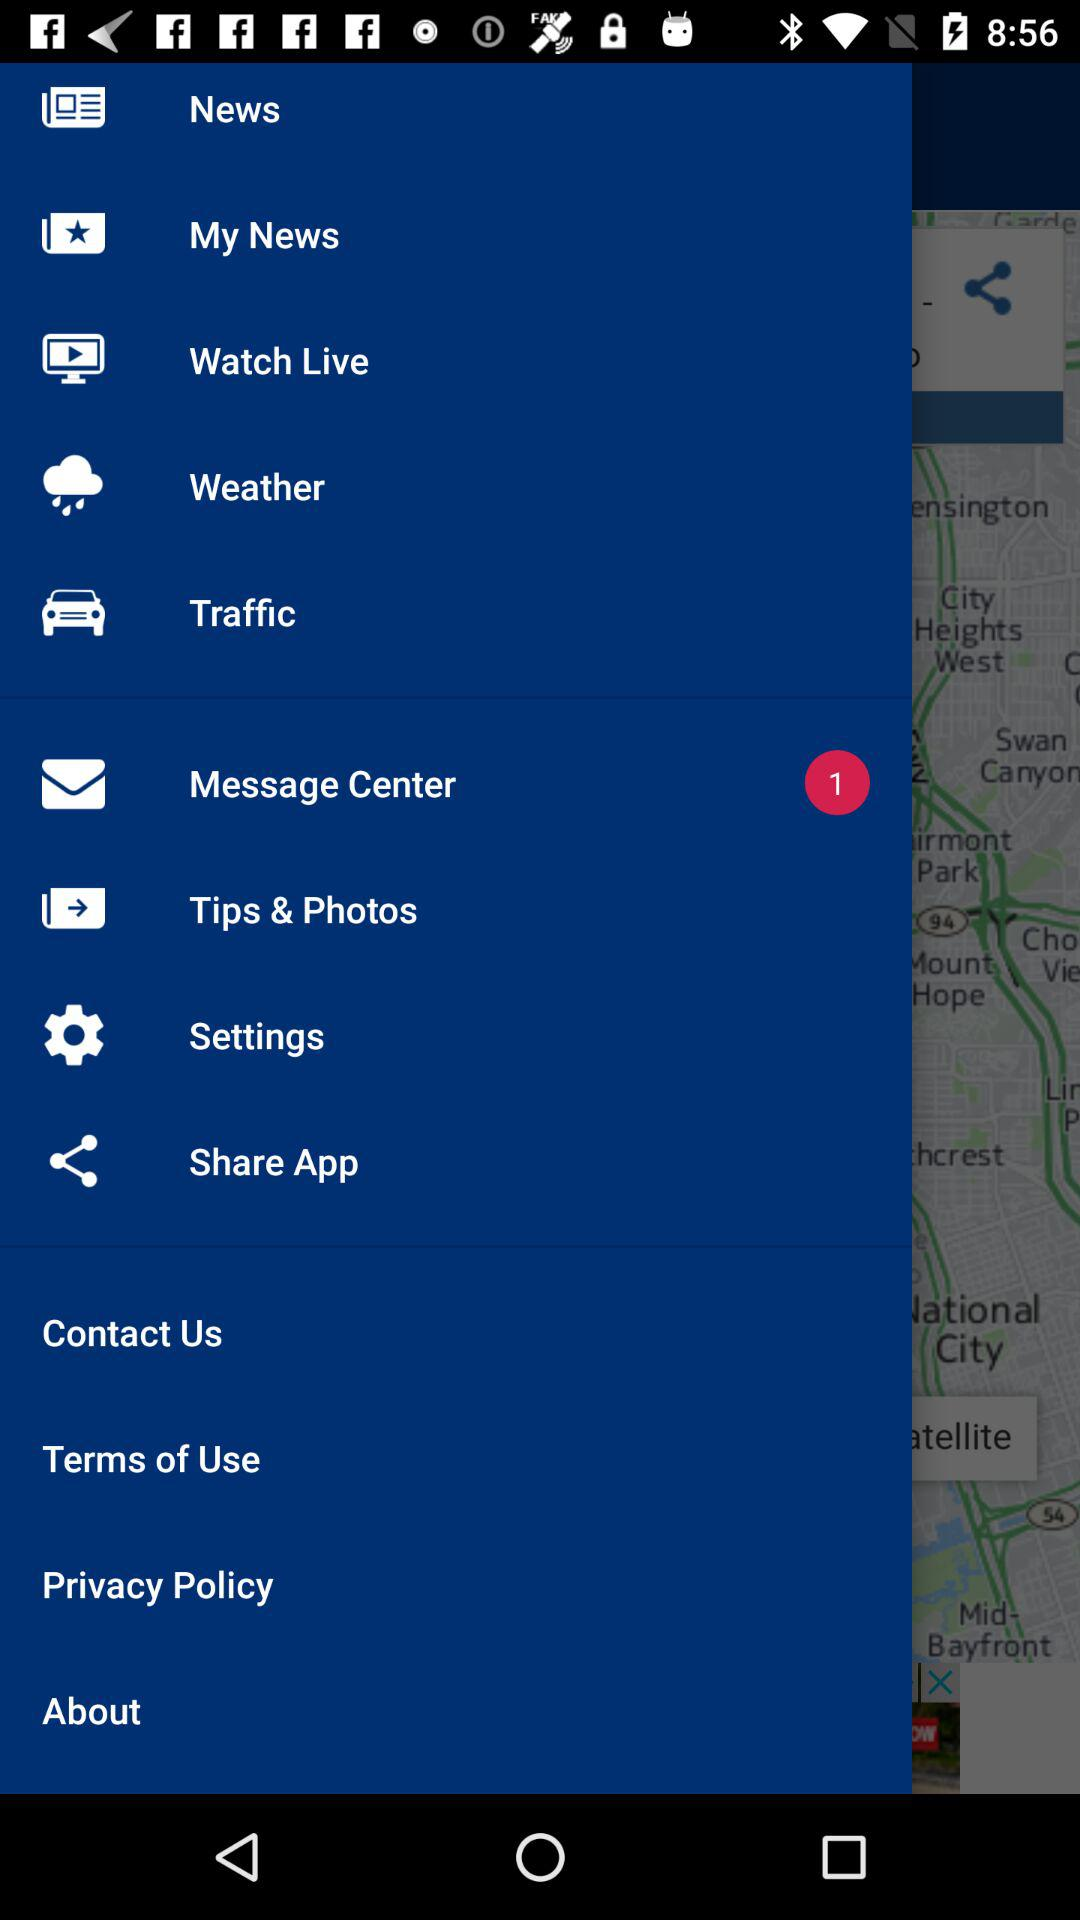How many messages are received? There is 1 message received. 